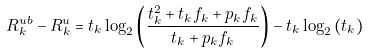Convert formula to latex. <formula><loc_0><loc_0><loc_500><loc_500>R ^ { u b } _ { k } - R ^ { u } _ { k } & = t _ { k } \log _ { 2 } \left ( \frac { t ^ { 2 } _ { k } + t _ { k } f _ { k } + p _ { k } f _ { k } } { t _ { k } + p _ { k } f _ { k } } \right ) - t _ { k } \log _ { 2 } \left ( t _ { k } \right ) \\</formula> 